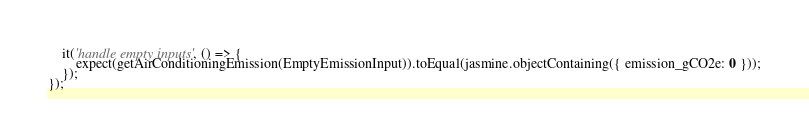<code> <loc_0><loc_0><loc_500><loc_500><_TypeScript_>    it('handle empty inputs', () => {
        expect(getAirConditioningEmission(EmptyEmissionInput)).toEqual(jasmine.objectContaining({ emission_gCO2e: 0 }));
    });
});</code> 